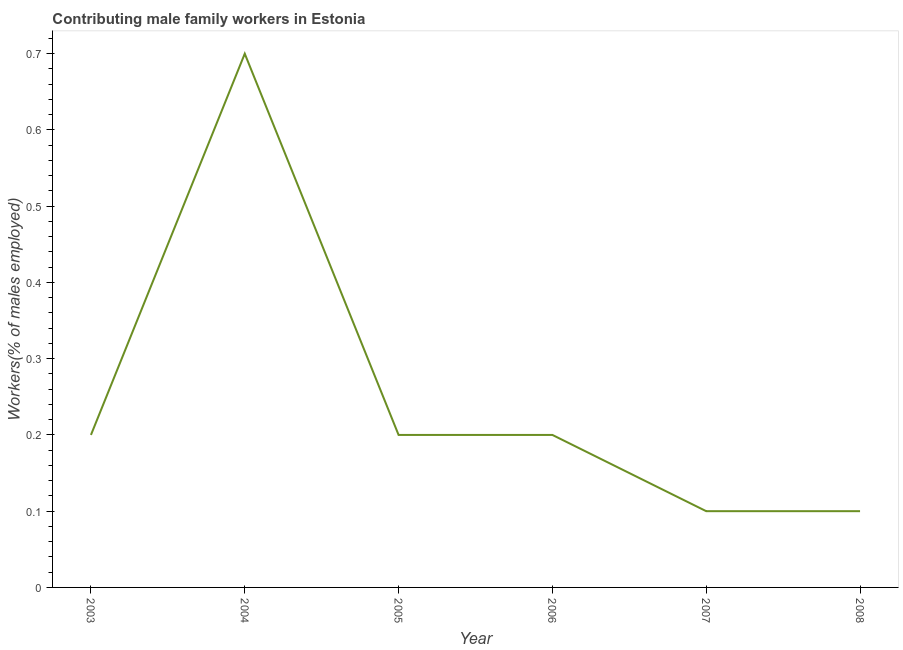What is the contributing male family workers in 2008?
Ensure brevity in your answer.  0.1. Across all years, what is the maximum contributing male family workers?
Offer a terse response. 0.7. Across all years, what is the minimum contributing male family workers?
Provide a short and direct response. 0.1. What is the sum of the contributing male family workers?
Ensure brevity in your answer.  1.5. What is the difference between the contributing male family workers in 2006 and 2008?
Make the answer very short. 0.1. What is the average contributing male family workers per year?
Ensure brevity in your answer.  0.25. What is the median contributing male family workers?
Give a very brief answer. 0.2. Do a majority of the years between 2004 and 2003 (inclusive) have contributing male family workers greater than 0.4 %?
Provide a short and direct response. No. Is the contributing male family workers in 2003 less than that in 2007?
Give a very brief answer. No. Is the difference between the contributing male family workers in 2006 and 2007 greater than the difference between any two years?
Your response must be concise. No. What is the difference between the highest and the second highest contributing male family workers?
Offer a terse response. 0.5. Is the sum of the contributing male family workers in 2005 and 2006 greater than the maximum contributing male family workers across all years?
Provide a short and direct response. No. What is the difference between the highest and the lowest contributing male family workers?
Keep it short and to the point. 0.6. Does the contributing male family workers monotonically increase over the years?
Make the answer very short. No. What is the title of the graph?
Offer a terse response. Contributing male family workers in Estonia. What is the label or title of the Y-axis?
Provide a short and direct response. Workers(% of males employed). What is the Workers(% of males employed) of 2003?
Your answer should be very brief. 0.2. What is the Workers(% of males employed) of 2004?
Your response must be concise. 0.7. What is the Workers(% of males employed) in 2005?
Provide a short and direct response. 0.2. What is the Workers(% of males employed) of 2006?
Give a very brief answer. 0.2. What is the Workers(% of males employed) in 2007?
Your answer should be very brief. 0.1. What is the Workers(% of males employed) of 2008?
Your answer should be very brief. 0.1. What is the difference between the Workers(% of males employed) in 2003 and 2005?
Give a very brief answer. 0. What is the difference between the Workers(% of males employed) in 2003 and 2007?
Your response must be concise. 0.1. What is the difference between the Workers(% of males employed) in 2004 and 2005?
Keep it short and to the point. 0.5. What is the difference between the Workers(% of males employed) in 2004 and 2007?
Provide a short and direct response. 0.6. What is the difference between the Workers(% of males employed) in 2004 and 2008?
Your answer should be compact. 0.6. What is the difference between the Workers(% of males employed) in 2005 and 2006?
Provide a succinct answer. 0. What is the difference between the Workers(% of males employed) in 2006 and 2008?
Provide a short and direct response. 0.1. What is the ratio of the Workers(% of males employed) in 2003 to that in 2004?
Offer a terse response. 0.29. What is the ratio of the Workers(% of males employed) in 2003 to that in 2005?
Provide a succinct answer. 1. What is the ratio of the Workers(% of males employed) in 2003 to that in 2007?
Offer a terse response. 2. What is the ratio of the Workers(% of males employed) in 2003 to that in 2008?
Keep it short and to the point. 2. What is the ratio of the Workers(% of males employed) in 2004 to that in 2005?
Your answer should be very brief. 3.5. What is the ratio of the Workers(% of males employed) in 2005 to that in 2008?
Offer a very short reply. 2. What is the ratio of the Workers(% of males employed) in 2006 to that in 2008?
Offer a terse response. 2. 